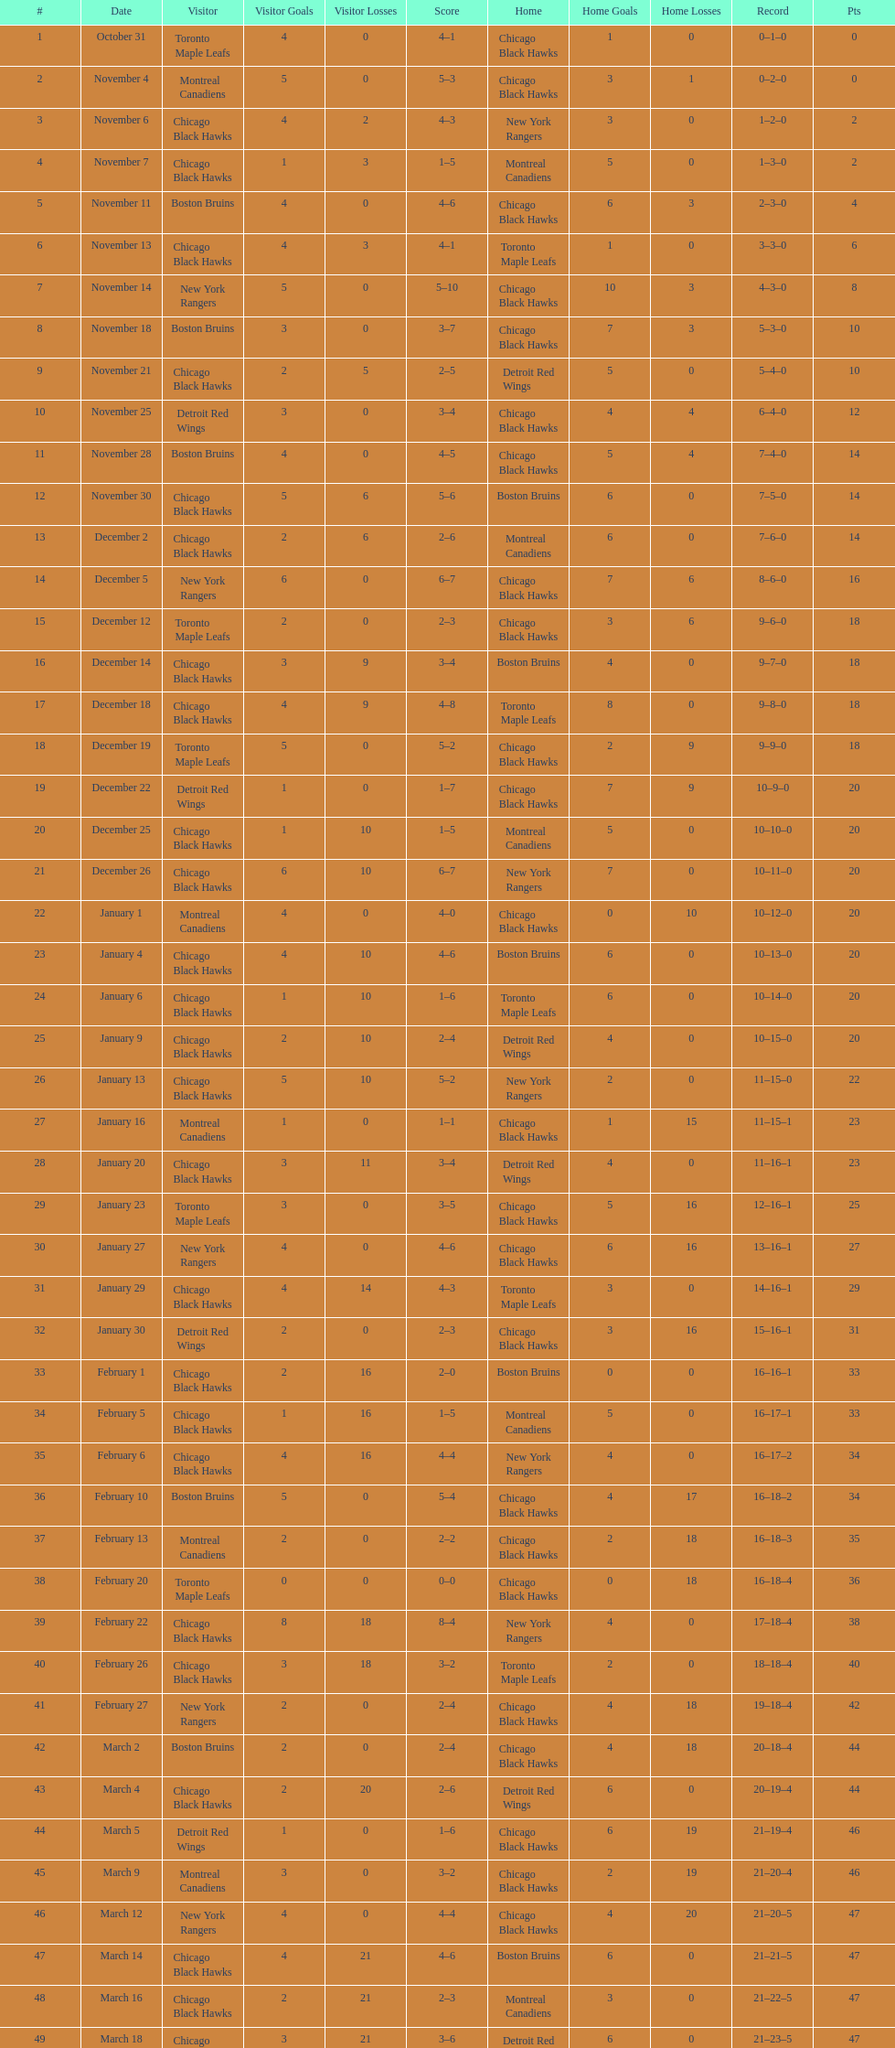How many games were played in total? 50. 